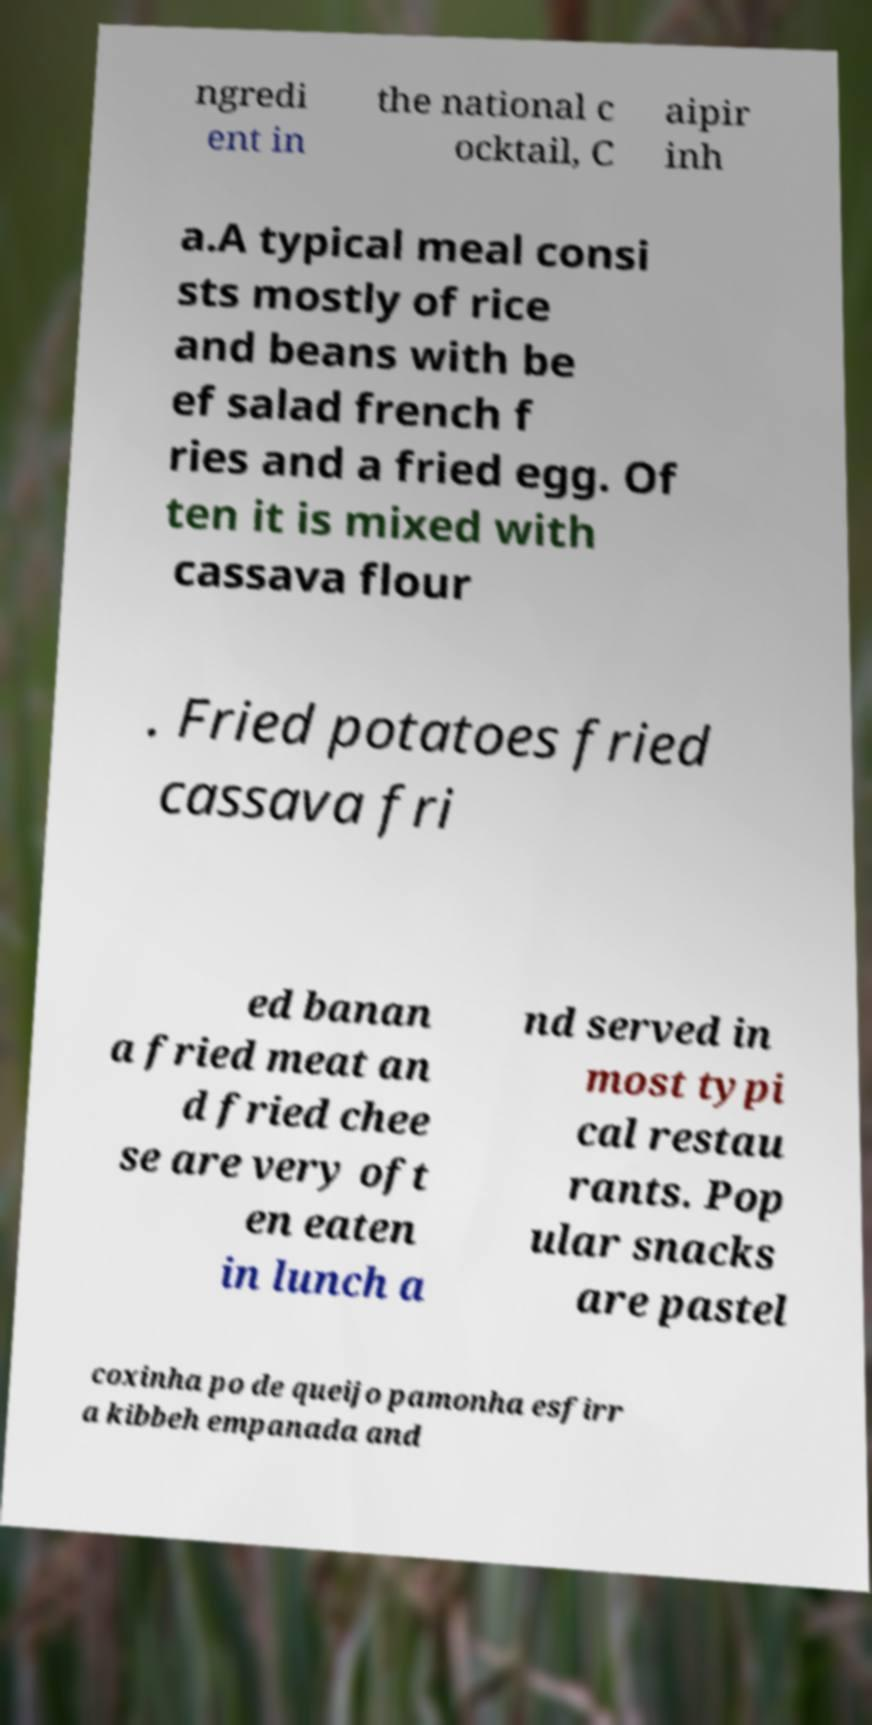What messages or text are displayed in this image? I need them in a readable, typed format. ngredi ent in the national c ocktail, C aipir inh a.A typical meal consi sts mostly of rice and beans with be ef salad french f ries and a fried egg. Of ten it is mixed with cassava flour . Fried potatoes fried cassava fri ed banan a fried meat an d fried chee se are very oft en eaten in lunch a nd served in most typi cal restau rants. Pop ular snacks are pastel coxinha po de queijo pamonha esfirr a kibbeh empanada and 